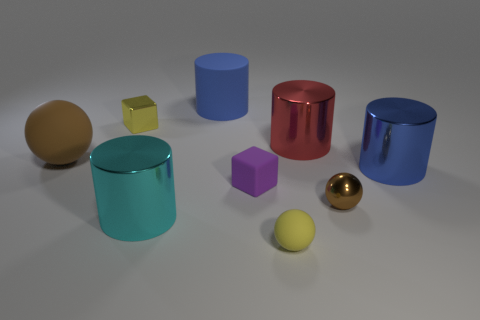How many tiny brown metal balls are there?
Give a very brief answer. 1. There is a yellow matte object; are there any yellow things left of it?
Your answer should be very brief. Yes. Is the material of the yellow thing behind the large brown rubber object the same as the sphere on the left side of the purple object?
Offer a very short reply. No. Are there fewer brown spheres to the right of the large red shiny thing than red metallic cylinders?
Keep it short and to the point. No. What is the color of the big object on the left side of the tiny yellow cube?
Offer a very short reply. Brown. What material is the brown thing that is on the left side of the blue cylinder that is behind the large red cylinder?
Your answer should be compact. Rubber. Are there any red metal things of the same size as the cyan thing?
Provide a short and direct response. Yes. What number of things are cylinders right of the big brown sphere or cylinders that are in front of the purple cube?
Ensure brevity in your answer.  4. Do the yellow object behind the small yellow sphere and the cube that is to the right of the large blue rubber cylinder have the same size?
Provide a short and direct response. Yes. There is a tiny shiny thing to the right of the tiny yellow matte thing; is there a small purple cube behind it?
Give a very brief answer. Yes. 